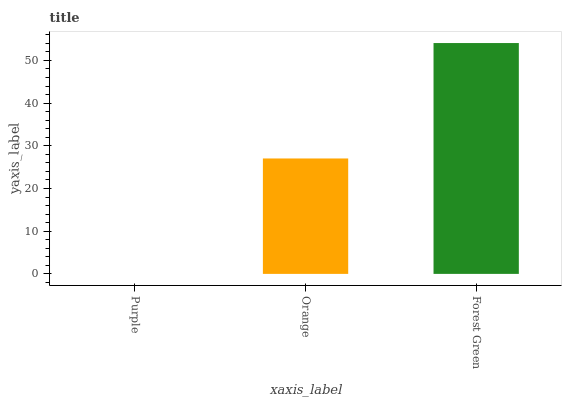Is Purple the minimum?
Answer yes or no. Yes. Is Forest Green the maximum?
Answer yes or no. Yes. Is Orange the minimum?
Answer yes or no. No. Is Orange the maximum?
Answer yes or no. No. Is Orange greater than Purple?
Answer yes or no. Yes. Is Purple less than Orange?
Answer yes or no. Yes. Is Purple greater than Orange?
Answer yes or no. No. Is Orange less than Purple?
Answer yes or no. No. Is Orange the high median?
Answer yes or no. Yes. Is Orange the low median?
Answer yes or no. Yes. Is Forest Green the high median?
Answer yes or no. No. Is Forest Green the low median?
Answer yes or no. No. 